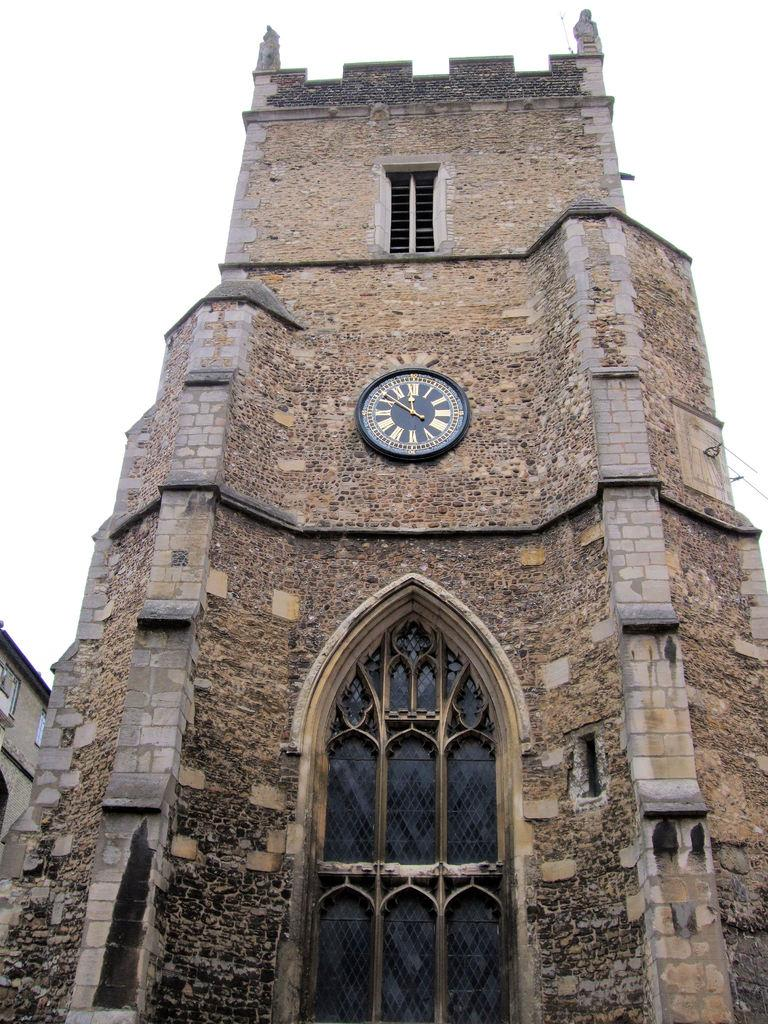Provide a one-sentence caption for the provided image. The watch on the tower is set at 10. 